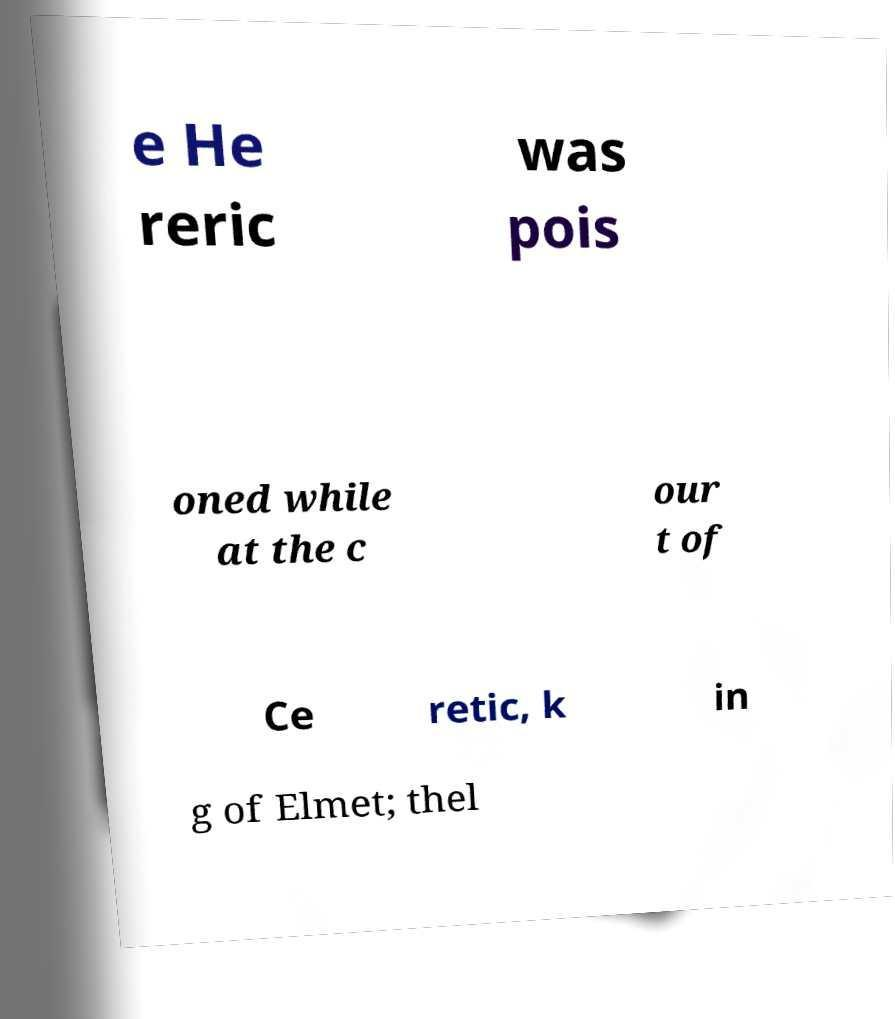Could you assist in decoding the text presented in this image and type it out clearly? e He reric was pois oned while at the c our t of Ce retic, k in g of Elmet; thel 